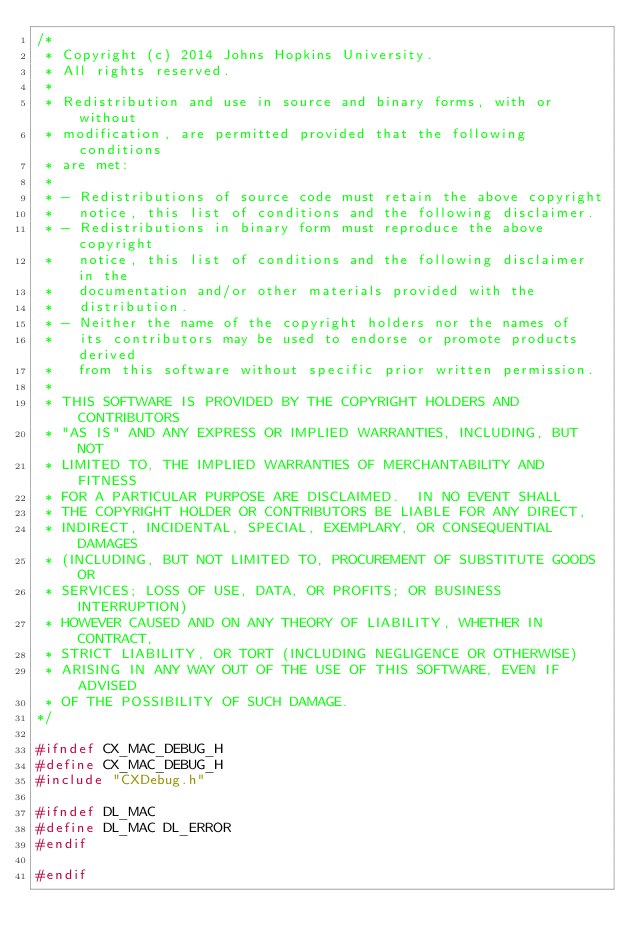Convert code to text. <code><loc_0><loc_0><loc_500><loc_500><_C_>/*
 * Copyright (c) 2014 Johns Hopkins University.
 * All rights reserved.
 *
 * Redistribution and use in source and binary forms, with or without
 * modification, are permitted provided that the following conditions
 * are met:
 *
 * - Redistributions of source code must retain the above copyright
 *   notice, this list of conditions and the following disclaimer.
 * - Redistributions in binary form must reproduce the above copyright
 *   notice, this list of conditions and the following disclaimer in the
 *   documentation and/or other materials provided with the
 *   distribution.
 * - Neither the name of the copyright holders nor the names of
 *   its contributors may be used to endorse or promote products derived
 *   from this software without specific prior written permission.
 *
 * THIS SOFTWARE IS PROVIDED BY THE COPYRIGHT HOLDERS AND CONTRIBUTORS
 * "AS IS" AND ANY EXPRESS OR IMPLIED WARRANTIES, INCLUDING, BUT NOT
 * LIMITED TO, THE IMPLIED WARRANTIES OF MERCHANTABILITY AND FITNESS
 * FOR A PARTICULAR PURPOSE ARE DISCLAIMED.  IN NO EVENT SHALL
 * THE COPYRIGHT HOLDER OR CONTRIBUTORS BE LIABLE FOR ANY DIRECT,
 * INDIRECT, INCIDENTAL, SPECIAL, EXEMPLARY, OR CONSEQUENTIAL DAMAGES
 * (INCLUDING, BUT NOT LIMITED TO, PROCUREMENT OF SUBSTITUTE GOODS OR
 * SERVICES; LOSS OF USE, DATA, OR PROFITS; OR BUSINESS INTERRUPTION)
 * HOWEVER CAUSED AND ON ANY THEORY OF LIABILITY, WHETHER IN CONTRACT,
 * STRICT LIABILITY, OR TORT (INCLUDING NEGLIGENCE OR OTHERWISE)
 * ARISING IN ANY WAY OUT OF THE USE OF THIS SOFTWARE, EVEN IF ADVISED
 * OF THE POSSIBILITY OF SUCH DAMAGE.
*/

#ifndef CX_MAC_DEBUG_H
#define CX_MAC_DEBUG_H
#include "CXDebug.h"

#ifndef DL_MAC
#define DL_MAC DL_ERROR
#endif

#endif

</code> 